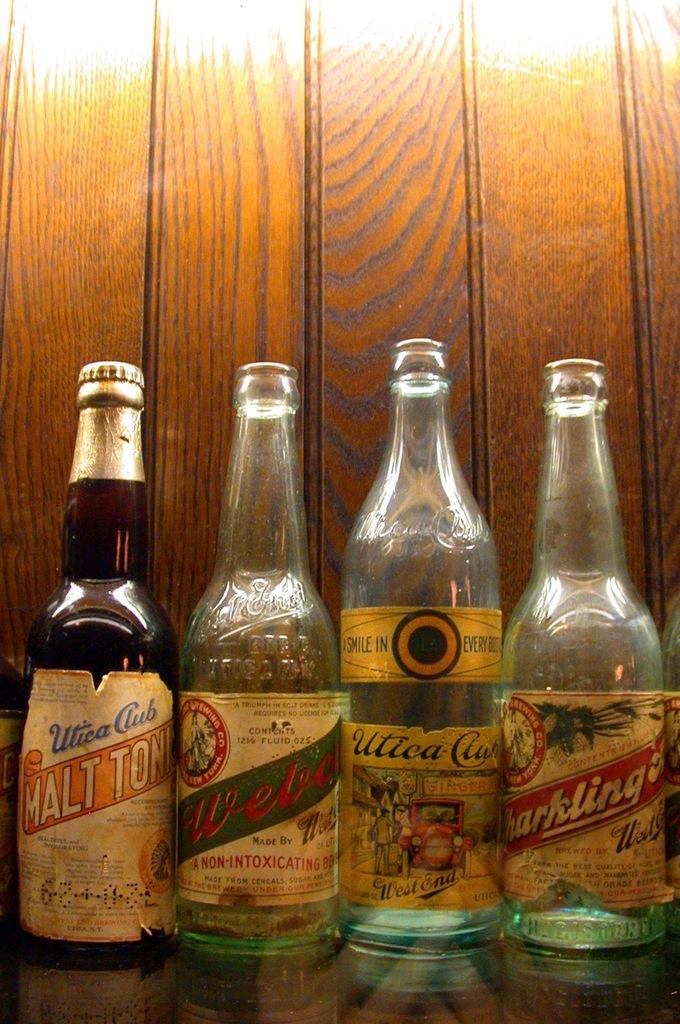What kind of drink is in the bottle on the left?
Make the answer very short. Malt tonic. Does one of the bottles say west end?
Offer a very short reply. Yes. 